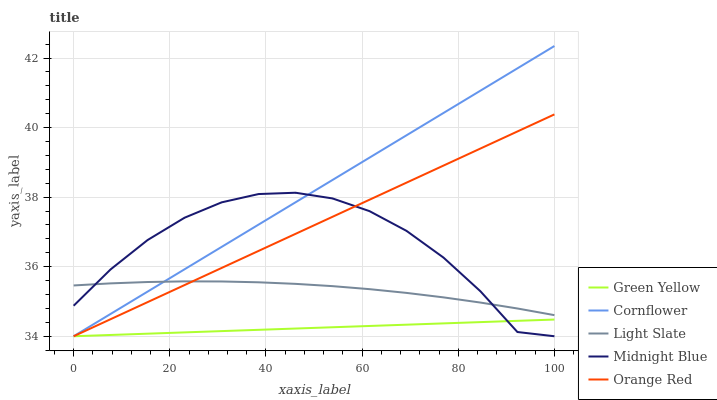Does Green Yellow have the minimum area under the curve?
Answer yes or no. Yes. Does Cornflower have the maximum area under the curve?
Answer yes or no. Yes. Does Cornflower have the minimum area under the curve?
Answer yes or no. No. Does Green Yellow have the maximum area under the curve?
Answer yes or no. No. Is Orange Red the smoothest?
Answer yes or no. Yes. Is Midnight Blue the roughest?
Answer yes or no. Yes. Is Cornflower the smoothest?
Answer yes or no. No. Is Cornflower the roughest?
Answer yes or no. No. Does Cornflower have the lowest value?
Answer yes or no. Yes. Does Cornflower have the highest value?
Answer yes or no. Yes. Does Green Yellow have the highest value?
Answer yes or no. No. Is Green Yellow less than Light Slate?
Answer yes or no. Yes. Is Light Slate greater than Green Yellow?
Answer yes or no. Yes. Does Light Slate intersect Cornflower?
Answer yes or no. Yes. Is Light Slate less than Cornflower?
Answer yes or no. No. Is Light Slate greater than Cornflower?
Answer yes or no. No. Does Green Yellow intersect Light Slate?
Answer yes or no. No. 